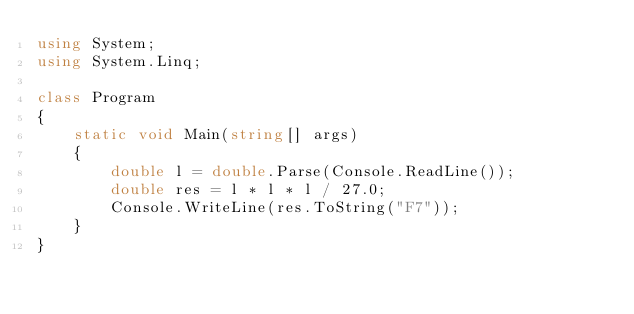Convert code to text. <code><loc_0><loc_0><loc_500><loc_500><_C#_>using System;
using System.Linq;

class Program
{
    static void Main(string[] args)
    {
        double l = double.Parse(Console.ReadLine());
        double res = l * l * l / 27.0;
        Console.WriteLine(res.ToString("F7"));
    }
}</code> 